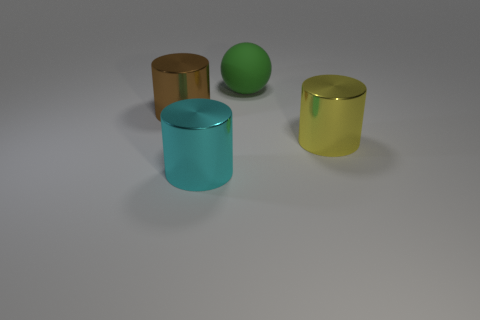Add 4 big green cylinders. How many objects exist? 8 Subtract all spheres. How many objects are left? 3 Add 1 brown metallic objects. How many brown metallic objects are left? 2 Add 4 large brown cylinders. How many large brown cylinders exist? 5 Subtract 1 green balls. How many objects are left? 3 Subtract all cyan metallic cylinders. Subtract all small purple balls. How many objects are left? 3 